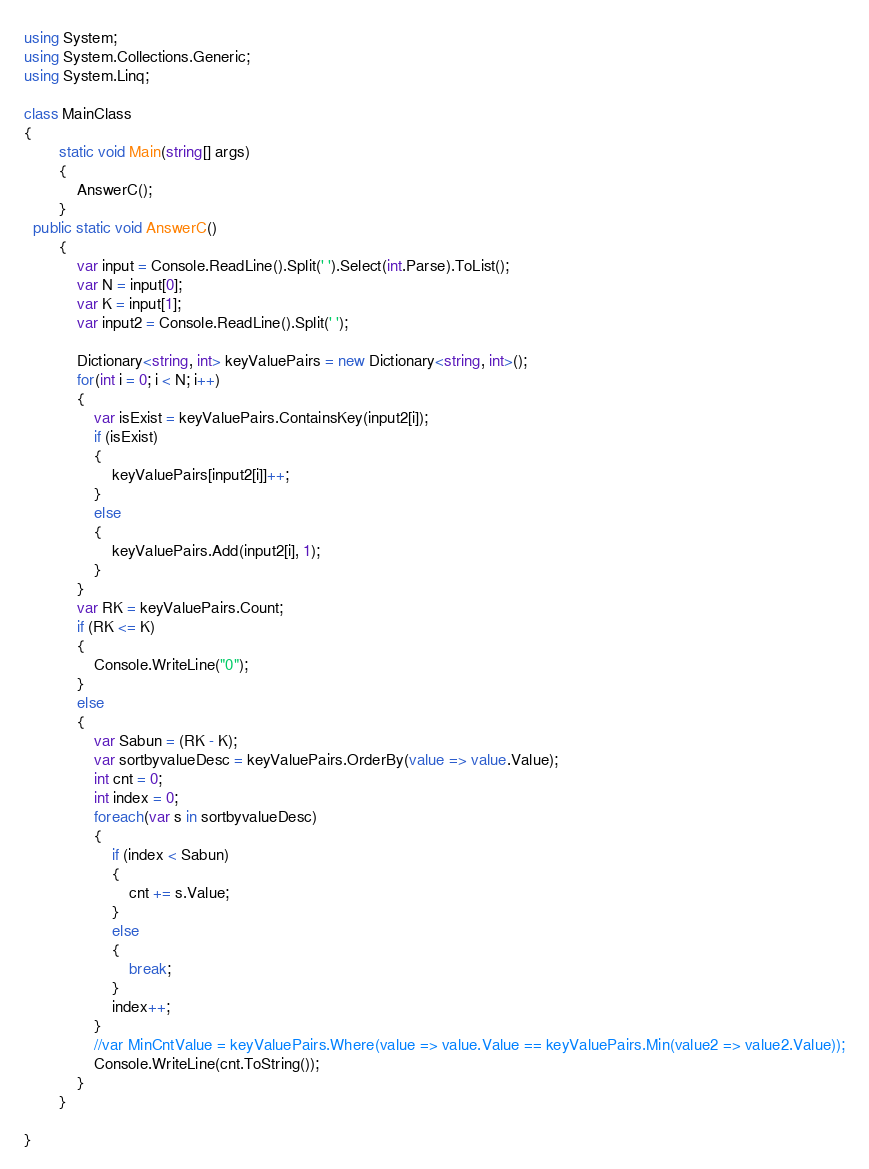Convert code to text. <code><loc_0><loc_0><loc_500><loc_500><_C#_>using System;
using System.Collections.Generic;
using System.Linq;

class MainClass
{
        static void Main(string[] args)
        {
			AnswerC();
        }
  public static void AnswerC()
		{
			var input = Console.ReadLine().Split(' ').Select(int.Parse).ToList();
			var N = input[0];
			var K = input[1];
			var input2 = Console.ReadLine().Split(' ');

			Dictionary<string, int> keyValuePairs = new Dictionary<string, int>();
			for(int i = 0; i < N; i++)
			{
				var isExist = keyValuePairs.ContainsKey(input2[i]);
				if (isExist)
				{
					keyValuePairs[input2[i]]++;
				}
				else
				{
					keyValuePairs.Add(input2[i], 1);
				}
			}
			var RK = keyValuePairs.Count;
			if (RK <= K)
			{
				Console.WriteLine("0");
			}
			else
			{
				var Sabun = (RK - K);
				var sortbyvalueDesc = keyValuePairs.OrderBy(value => value.Value);
				int cnt = 0;
				int index = 0;
				foreach(var s in sortbyvalueDesc)
				{
					if (index < Sabun)
					{
						cnt += s.Value;
					}
					else
					{
						break;
					}
					index++;
				}
				//var MinCntValue = keyValuePairs.Where(value => value.Value == keyValuePairs.Min(value2 => value2.Value));
				Console.WriteLine(cnt.ToString());
			}
		}
  
}
</code> 